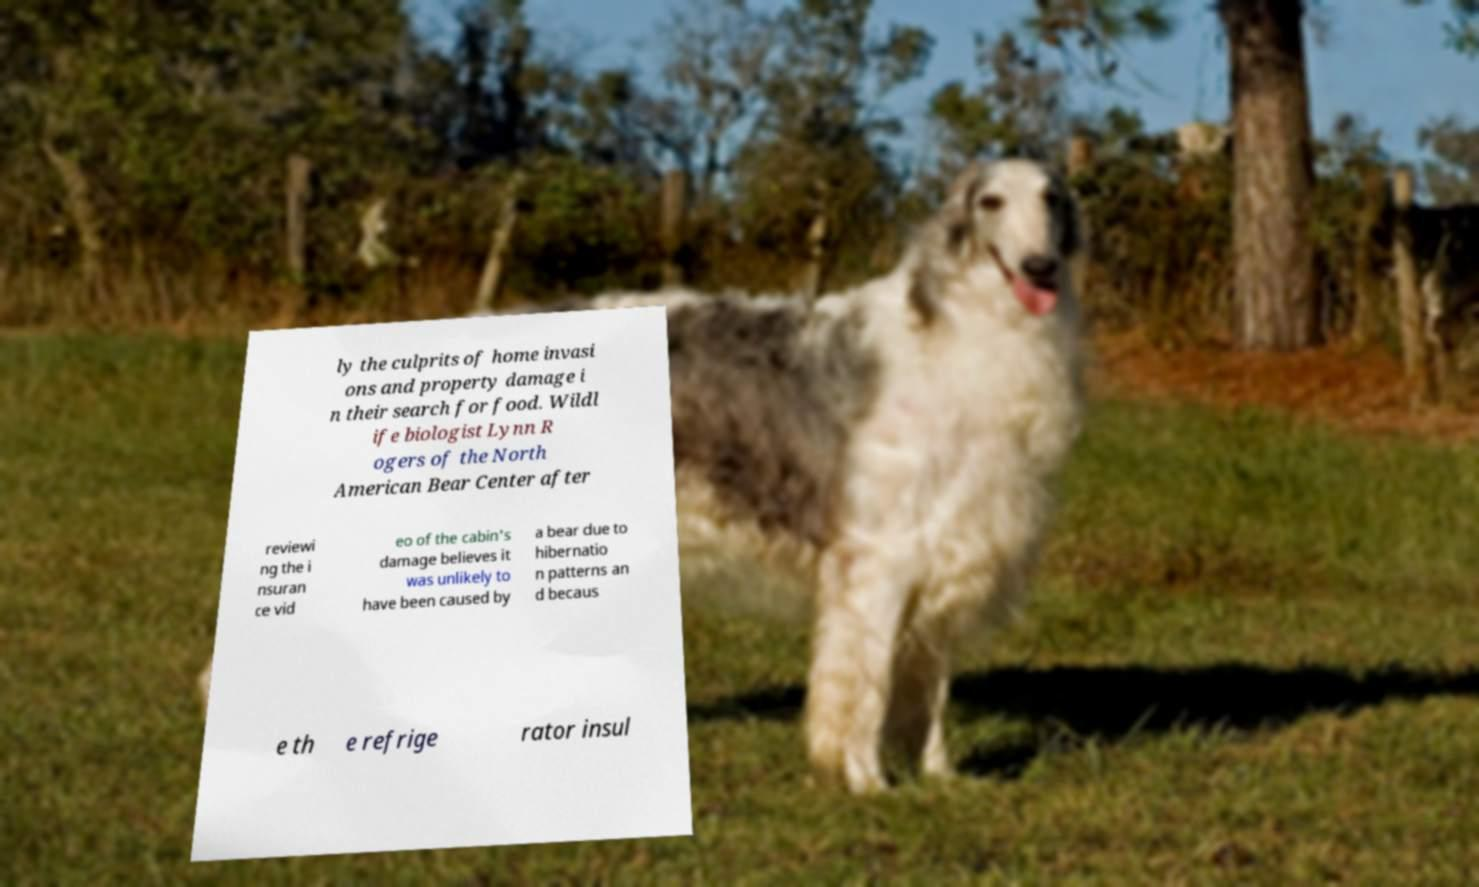Can you read and provide the text displayed in the image?This photo seems to have some interesting text. Can you extract and type it out for me? ly the culprits of home invasi ons and property damage i n their search for food. Wildl ife biologist Lynn R ogers of the North American Bear Center after reviewi ng the i nsuran ce vid eo of the cabin's damage believes it was unlikely to have been caused by a bear due to hibernatio n patterns an d becaus e th e refrige rator insul 